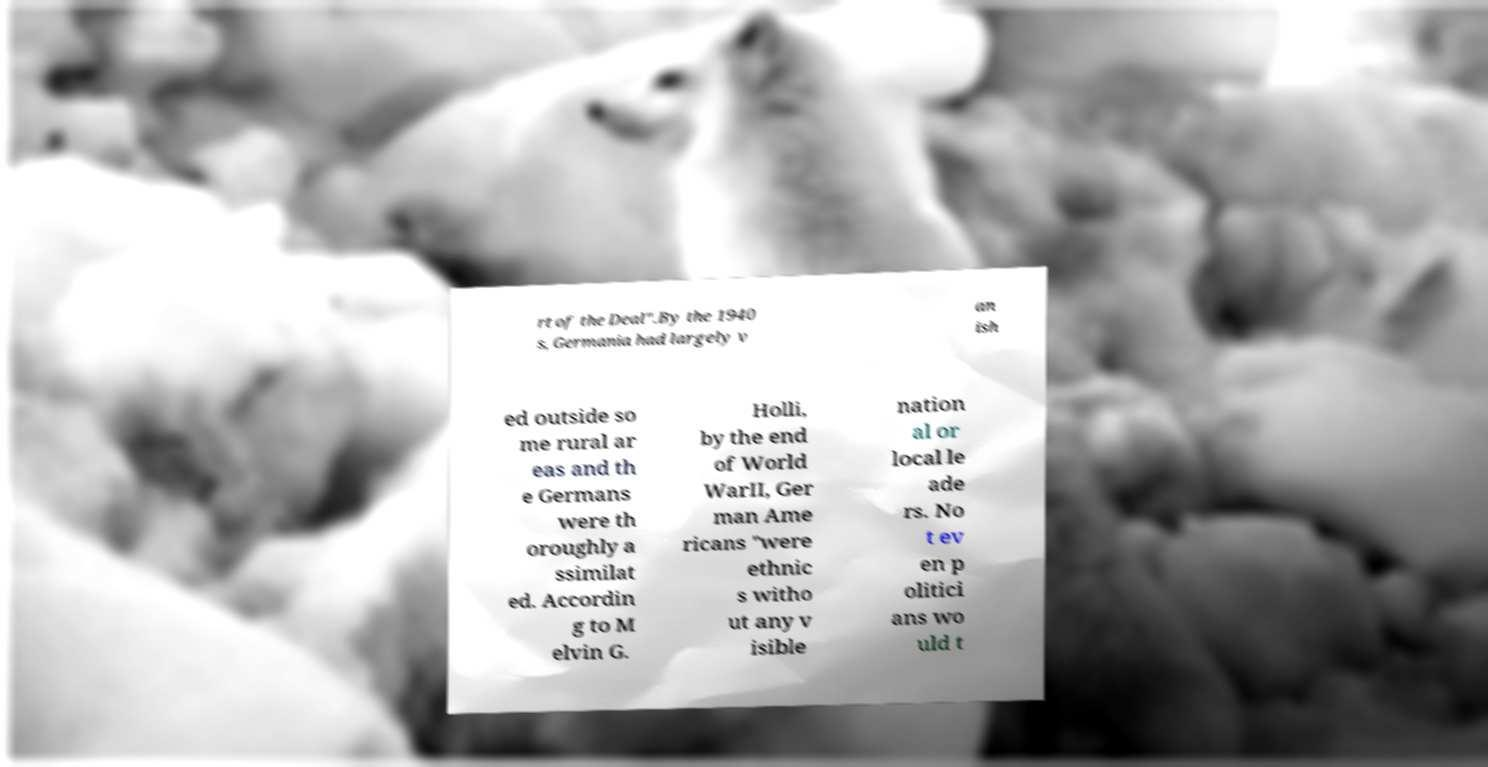What messages or text are displayed in this image? I need them in a readable, typed format. rt of the Deal".By the 1940 s, Germania had largely v an ish ed outside so me rural ar eas and th e Germans were th oroughly a ssimilat ed. Accordin g to M elvin G. Holli, by the end of World WarII, Ger man Ame ricans "were ethnic s witho ut any v isible nation al or local le ade rs. No t ev en p olitici ans wo uld t 